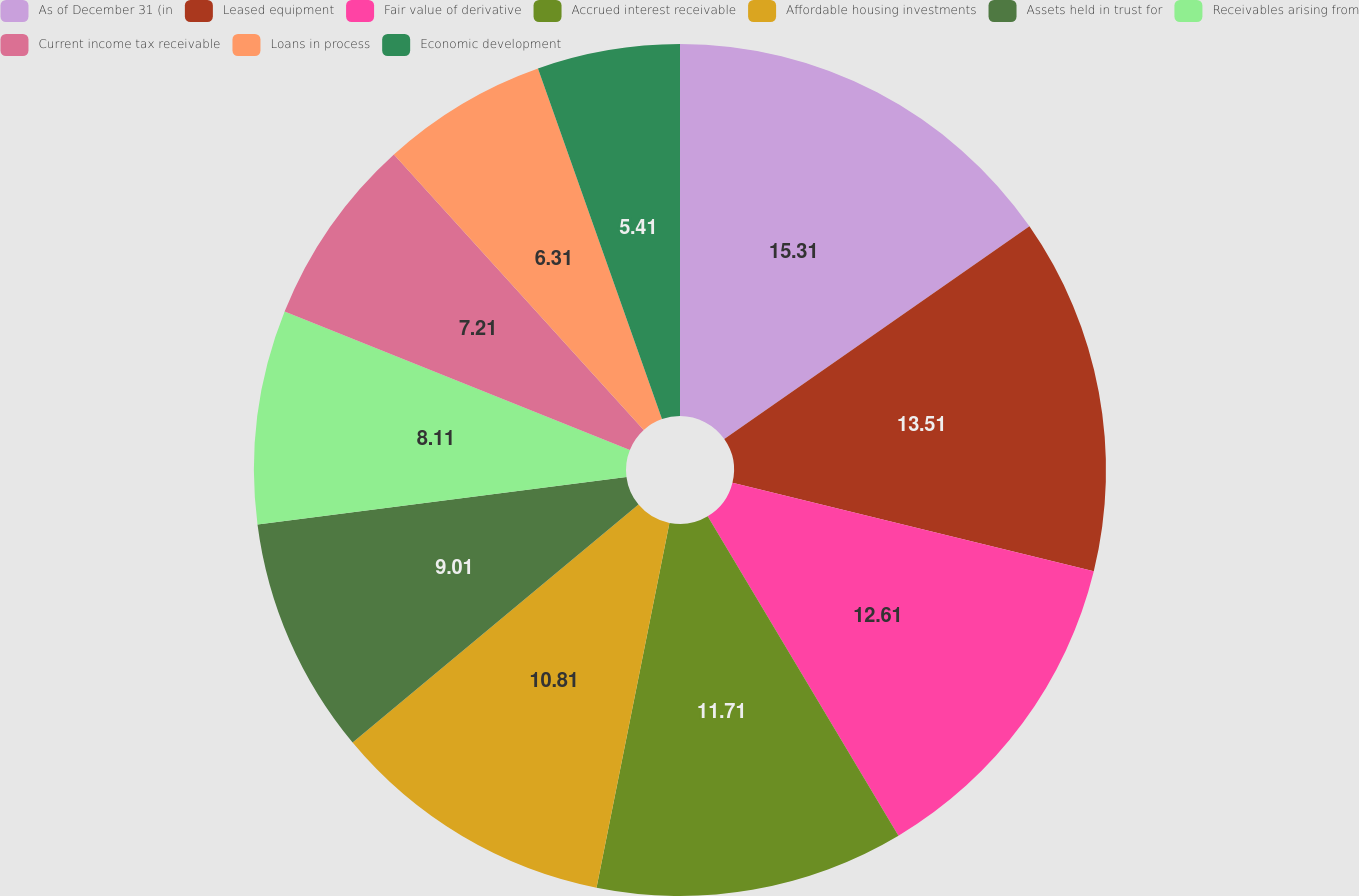Convert chart. <chart><loc_0><loc_0><loc_500><loc_500><pie_chart><fcel>As of December 31 (in<fcel>Leased equipment<fcel>Fair value of derivative<fcel>Accrued interest receivable<fcel>Affordable housing investments<fcel>Assets held in trust for<fcel>Receivables arising from<fcel>Current income tax receivable<fcel>Loans in process<fcel>Economic development<nl><fcel>15.31%<fcel>13.51%<fcel>12.61%<fcel>11.71%<fcel>10.81%<fcel>9.01%<fcel>8.11%<fcel>7.21%<fcel>6.31%<fcel>5.41%<nl></chart> 